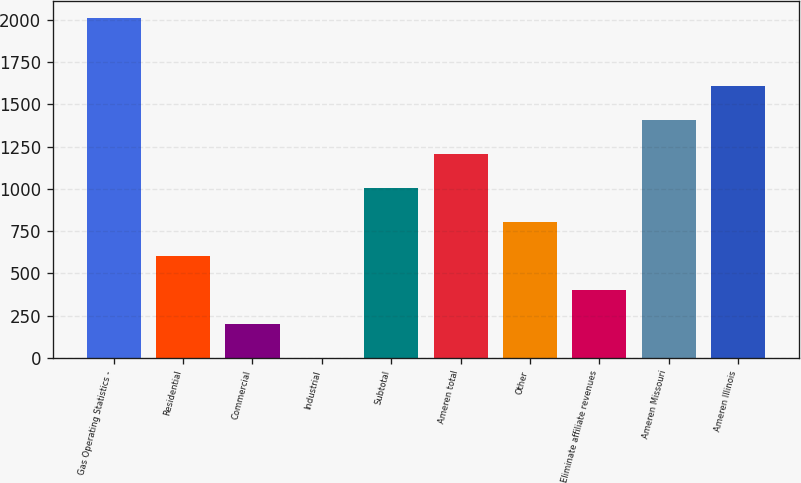Convert chart. <chart><loc_0><loc_0><loc_500><loc_500><bar_chart><fcel>Gas Operating Statistics -<fcel>Residential<fcel>Commercial<fcel>Industrial<fcel>Subtotal<fcel>Ameren total<fcel>Other<fcel>Eliminate affiliate revenues<fcel>Ameren Missouri<fcel>Ameren Illinois<nl><fcel>2009<fcel>603.4<fcel>201.8<fcel>1<fcel>1005<fcel>1205.8<fcel>804.2<fcel>402.6<fcel>1406.6<fcel>1607.4<nl></chart> 